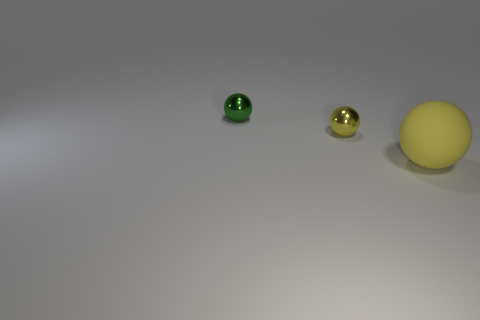Is there anything else that is the same material as the large sphere?
Provide a short and direct response. No. How many small metallic objects are the same color as the large object?
Your answer should be compact. 1. There is a shiny object behind the yellow shiny thing; how big is it?
Offer a very short reply. Small. What size is the other object that is the same color as the matte thing?
Your answer should be very brief. Small. Are there any tiny yellow spheres that have the same material as the green object?
Offer a very short reply. Yes. Are the small yellow object and the green ball made of the same material?
Your response must be concise. Yes. The shiny thing that is the same size as the green ball is what color?
Offer a very short reply. Yellow. How many other things are there of the same shape as the tiny green object?
Keep it short and to the point. 2. There is a matte ball; is its size the same as the yellow sphere that is behind the yellow matte object?
Offer a terse response. No. What number of things are either large yellow spheres or big purple objects?
Your response must be concise. 1. 